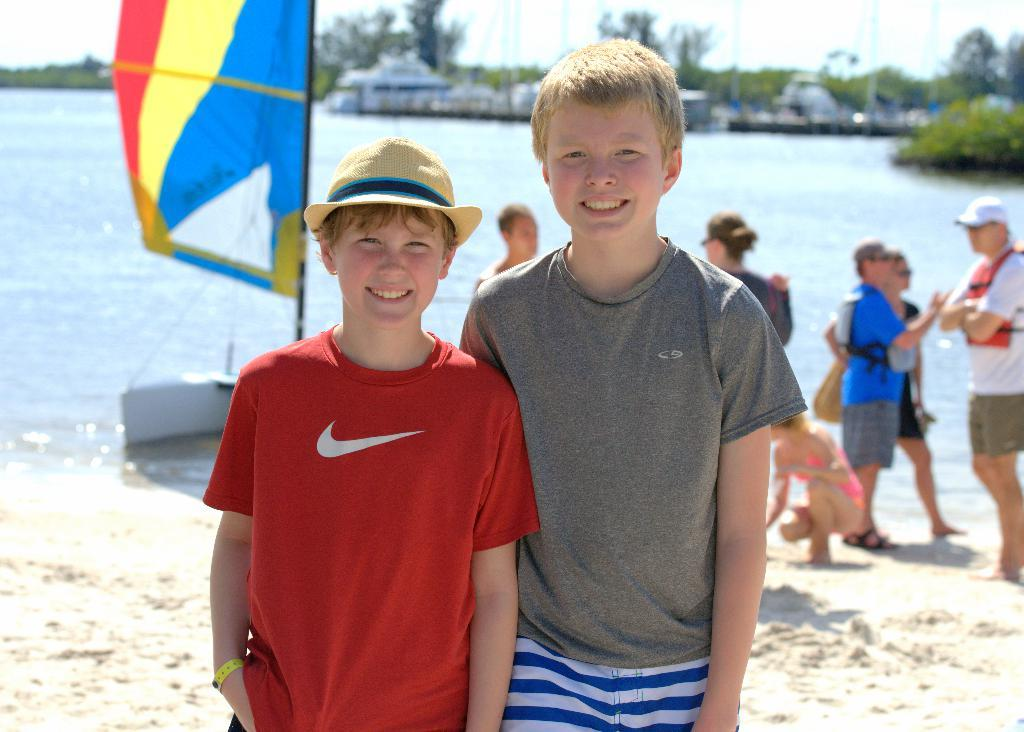Who or what can be seen in the image? There are people in the image. What is the main object in the water? There is a boat on the water in the image. What can be seen in the distance behind the boat? There are houses, trees, and the sky visible in the background of the image. What type of bulb is being used to illuminate the boat in the image? There is no bulb present in the image, as it is a scene outdoors with natural lighting from the sky. 